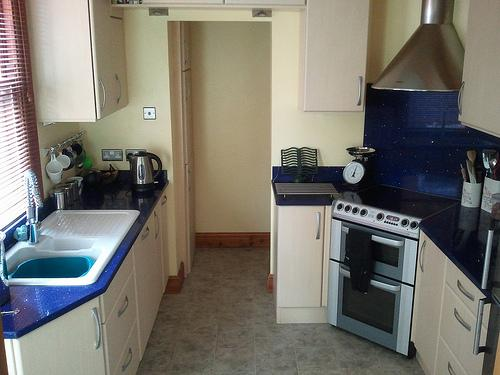In a single sentence, summarize the kitchen appliances present in the image. The image showcases a stainless steel stove, an electric coffee pot, a scale on the counter, and a faucet over a white sink. Describe the spatial arrangement of the objects around the sink in the image. Next to the sink, there is a blue countertop, a faucet positioned over the sink, and a window in the front. Cabinets are present under the sink. Explain where the kitchen utensils are stored in the image. The kitchen utensils are stored in a container sitting on the counter near the stove. Mention one distinctive feature of the counter in the image. The counter has a vibrant blue countertop that stands out in the kitchen. Mention a few items that are hanging or mounted in the kitchen in the image. Coffee mugs hanging from a metal rod, a dark dish towel hanging from the oven door, and white cups hanging from the wall are visible in the image. Describe the cooktop area and its surroundings in the image. The cooktop area includes a stainless steel stove, round dials for the oven, a stainless steel overhead exhaust, and a dark dish towel hanging from the oven door. Provide a brief overview of the central elements in the image. The image features a kitchen with a blue countertop, white cabinets, coffee mugs hanging on the wall, and various kitchen appliances such as a stove, a sink, and a coffee pot. List three prominent objects found within the kitchen. A silver coffee pot with black handles, turquoise plastic bin in the sink, and stainless steel stove are present in the kitchen. Identify the color scheme of the kitchen in the image. The kitchen has a vibrant blue countertop, white cabinets, and stainless steel appliances. List a few items that are placed on the kitchen counter. A food scale, a recipe book holder, a container holding kitchen utensils, and a blue bucket are placed on the kitchen counter. 